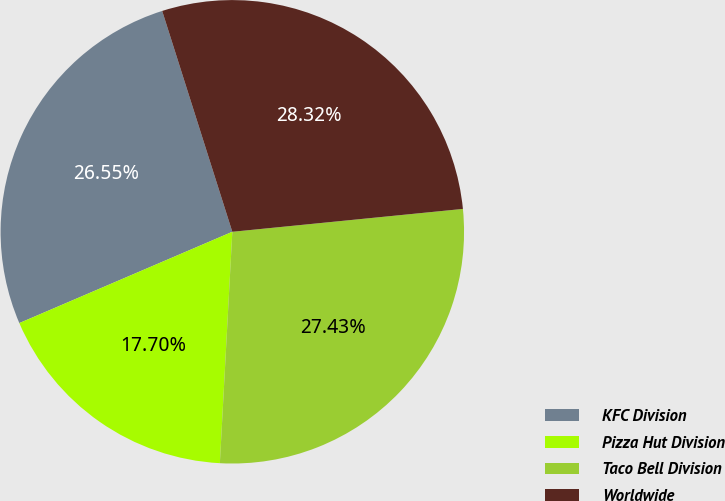Convert chart. <chart><loc_0><loc_0><loc_500><loc_500><pie_chart><fcel>KFC Division<fcel>Pizza Hut Division<fcel>Taco Bell Division<fcel>Worldwide<nl><fcel>26.55%<fcel>17.7%<fcel>27.43%<fcel>28.32%<nl></chart> 